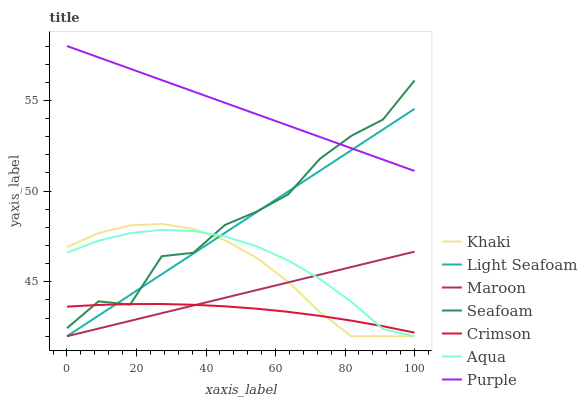Does Crimson have the minimum area under the curve?
Answer yes or no. Yes. Does Purple have the maximum area under the curve?
Answer yes or no. Yes. Does Aqua have the minimum area under the curve?
Answer yes or no. No. Does Aqua have the maximum area under the curve?
Answer yes or no. No. Is Maroon the smoothest?
Answer yes or no. Yes. Is Seafoam the roughest?
Answer yes or no. Yes. Is Purple the smoothest?
Answer yes or no. No. Is Purple the roughest?
Answer yes or no. No. Does Khaki have the lowest value?
Answer yes or no. Yes. Does Purple have the lowest value?
Answer yes or no. No. Does Purple have the highest value?
Answer yes or no. Yes. Does Aqua have the highest value?
Answer yes or no. No. Is Crimson less than Purple?
Answer yes or no. Yes. Is Purple greater than Aqua?
Answer yes or no. Yes. Does Aqua intersect Khaki?
Answer yes or no. Yes. Is Aqua less than Khaki?
Answer yes or no. No. Is Aqua greater than Khaki?
Answer yes or no. No. Does Crimson intersect Purple?
Answer yes or no. No. 